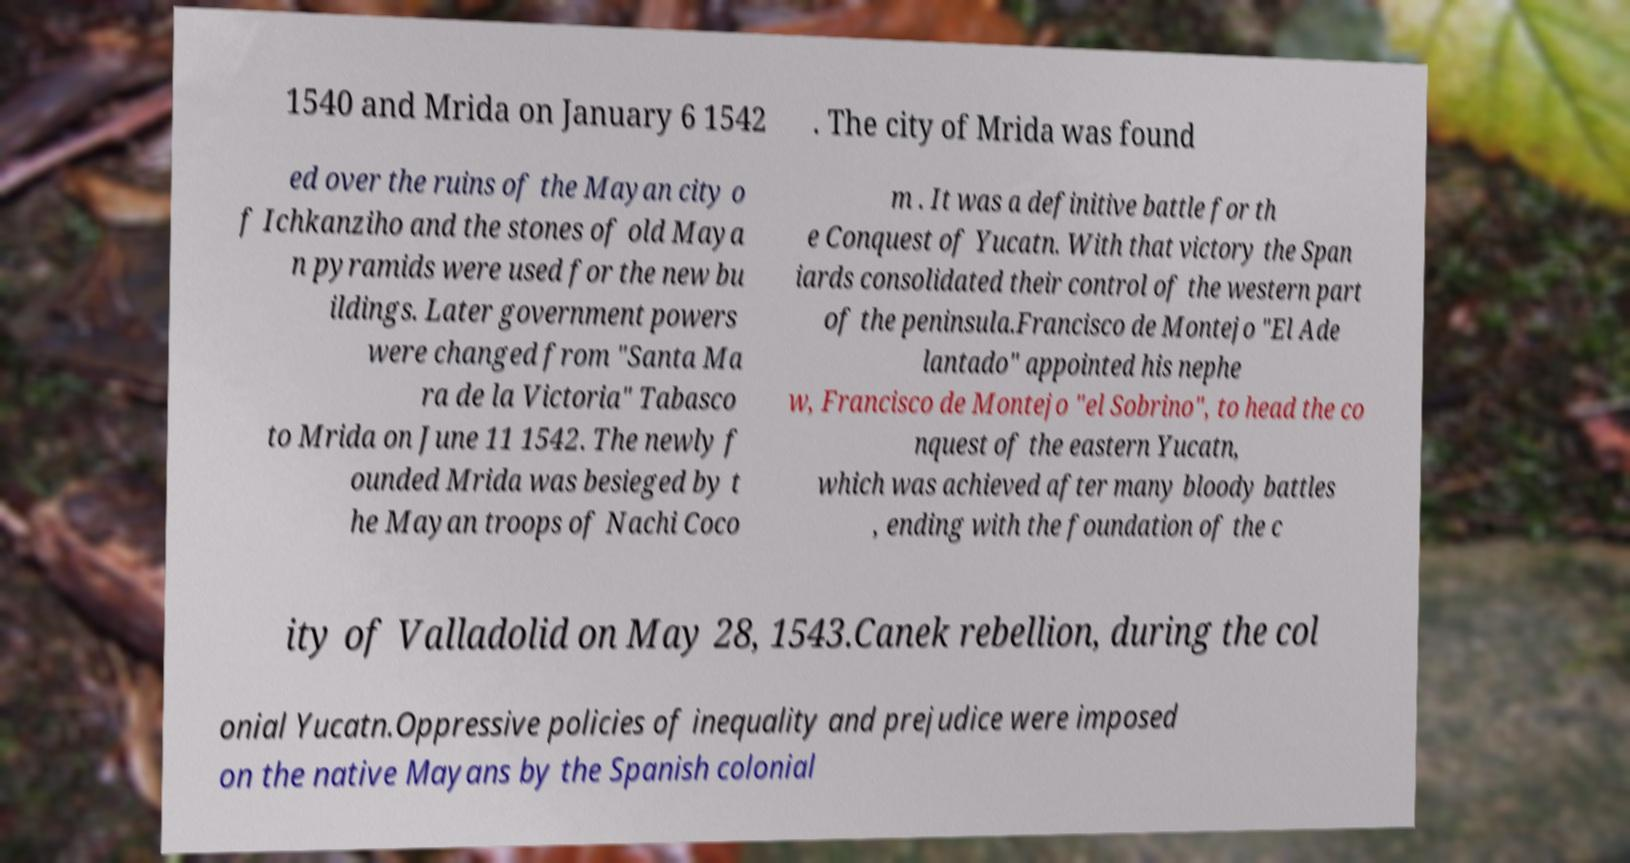Could you extract and type out the text from this image? 1540 and Mrida on January 6 1542 . The city of Mrida was found ed over the ruins of the Mayan city o f Ichkanziho and the stones of old Maya n pyramids were used for the new bu ildings. Later government powers were changed from "Santa Ma ra de la Victoria" Tabasco to Mrida on June 11 1542. The newly f ounded Mrida was besieged by t he Mayan troops of Nachi Coco m . It was a definitive battle for th e Conquest of Yucatn. With that victory the Span iards consolidated their control of the western part of the peninsula.Francisco de Montejo "El Ade lantado" appointed his nephe w, Francisco de Montejo "el Sobrino", to head the co nquest of the eastern Yucatn, which was achieved after many bloody battles , ending with the foundation of the c ity of Valladolid on May 28, 1543.Canek rebellion, during the col onial Yucatn.Oppressive policies of inequality and prejudice were imposed on the native Mayans by the Spanish colonial 